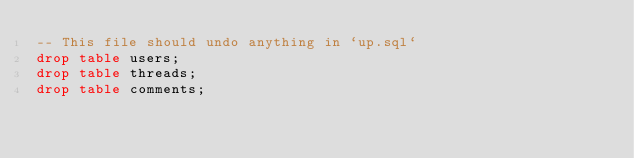Convert code to text. <code><loc_0><loc_0><loc_500><loc_500><_SQL_>-- This file should undo anything in `up.sql`
drop table users;
drop table threads;
drop table comments;
</code> 